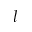<formula> <loc_0><loc_0><loc_500><loc_500>l</formula> 